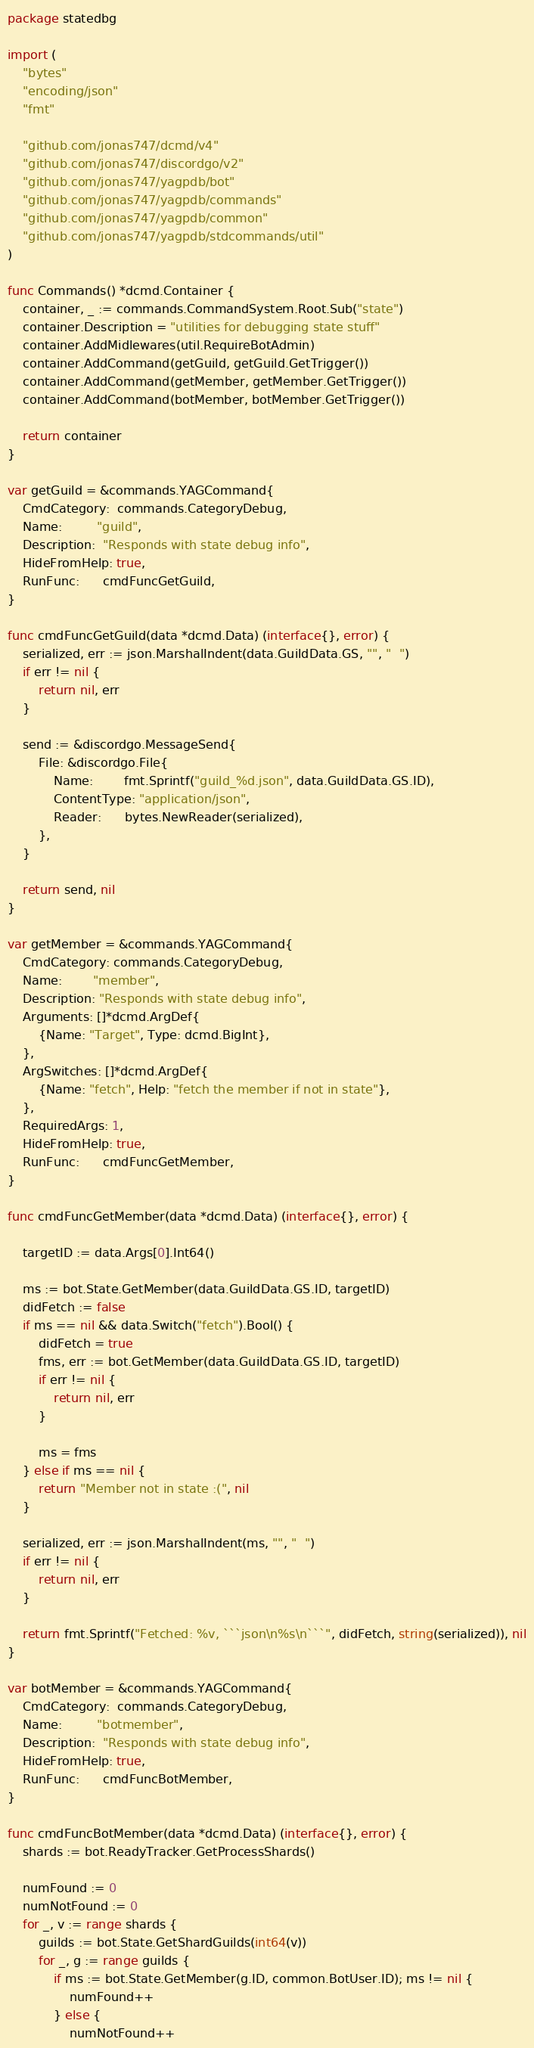<code> <loc_0><loc_0><loc_500><loc_500><_Go_>package statedbg

import (
	"bytes"
	"encoding/json"
	"fmt"

	"github.com/jonas747/dcmd/v4"
	"github.com/jonas747/discordgo/v2"
	"github.com/jonas747/yagpdb/bot"
	"github.com/jonas747/yagpdb/commands"
	"github.com/jonas747/yagpdb/common"
	"github.com/jonas747/yagpdb/stdcommands/util"
)

func Commands() *dcmd.Container {
	container, _ := commands.CommandSystem.Root.Sub("state")
	container.Description = "utilities for debugging state stuff"
	container.AddMidlewares(util.RequireBotAdmin)
	container.AddCommand(getGuild, getGuild.GetTrigger())
	container.AddCommand(getMember, getMember.GetTrigger())
	container.AddCommand(botMember, botMember.GetTrigger())

	return container
}

var getGuild = &commands.YAGCommand{
	CmdCategory:  commands.CategoryDebug,
	Name:         "guild",
	Description:  "Responds with state debug info",
	HideFromHelp: true,
	RunFunc:      cmdFuncGetGuild,
}

func cmdFuncGetGuild(data *dcmd.Data) (interface{}, error) {
	serialized, err := json.MarshalIndent(data.GuildData.GS, "", "  ")
	if err != nil {
		return nil, err
	}

	send := &discordgo.MessageSend{
		File: &discordgo.File{
			Name:        fmt.Sprintf("guild_%d.json", data.GuildData.GS.ID),
			ContentType: "application/json",
			Reader:      bytes.NewReader(serialized),
		},
	}

	return send, nil
}

var getMember = &commands.YAGCommand{
	CmdCategory: commands.CategoryDebug,
	Name:        "member",
	Description: "Responds with state debug info",
	Arguments: []*dcmd.ArgDef{
		{Name: "Target", Type: dcmd.BigInt},
	},
	ArgSwitches: []*dcmd.ArgDef{
		{Name: "fetch", Help: "fetch the member if not in state"},
	},
	RequiredArgs: 1,
	HideFromHelp: true,
	RunFunc:      cmdFuncGetMember,
}

func cmdFuncGetMember(data *dcmd.Data) (interface{}, error) {

	targetID := data.Args[0].Int64()

	ms := bot.State.GetMember(data.GuildData.GS.ID, targetID)
	didFetch := false
	if ms == nil && data.Switch("fetch").Bool() {
		didFetch = true
		fms, err := bot.GetMember(data.GuildData.GS.ID, targetID)
		if err != nil {
			return nil, err
		}

		ms = fms
	} else if ms == nil {
		return "Member not in state :(", nil
	}

	serialized, err := json.MarshalIndent(ms, "", "  ")
	if err != nil {
		return nil, err
	}

	return fmt.Sprintf("Fetched: %v, ```json\n%s\n```", didFetch, string(serialized)), nil
}

var botMember = &commands.YAGCommand{
	CmdCategory:  commands.CategoryDebug,
	Name:         "botmember",
	Description:  "Responds with state debug info",
	HideFromHelp: true,
	RunFunc:      cmdFuncBotMember,
}

func cmdFuncBotMember(data *dcmd.Data) (interface{}, error) {
	shards := bot.ReadyTracker.GetProcessShards()

	numFound := 0
	numNotFound := 0
	for _, v := range shards {
		guilds := bot.State.GetShardGuilds(int64(v))
		for _, g := range guilds {
			if ms := bot.State.GetMember(g.ID, common.BotUser.ID); ms != nil {
				numFound++
			} else {
				numNotFound++</code> 